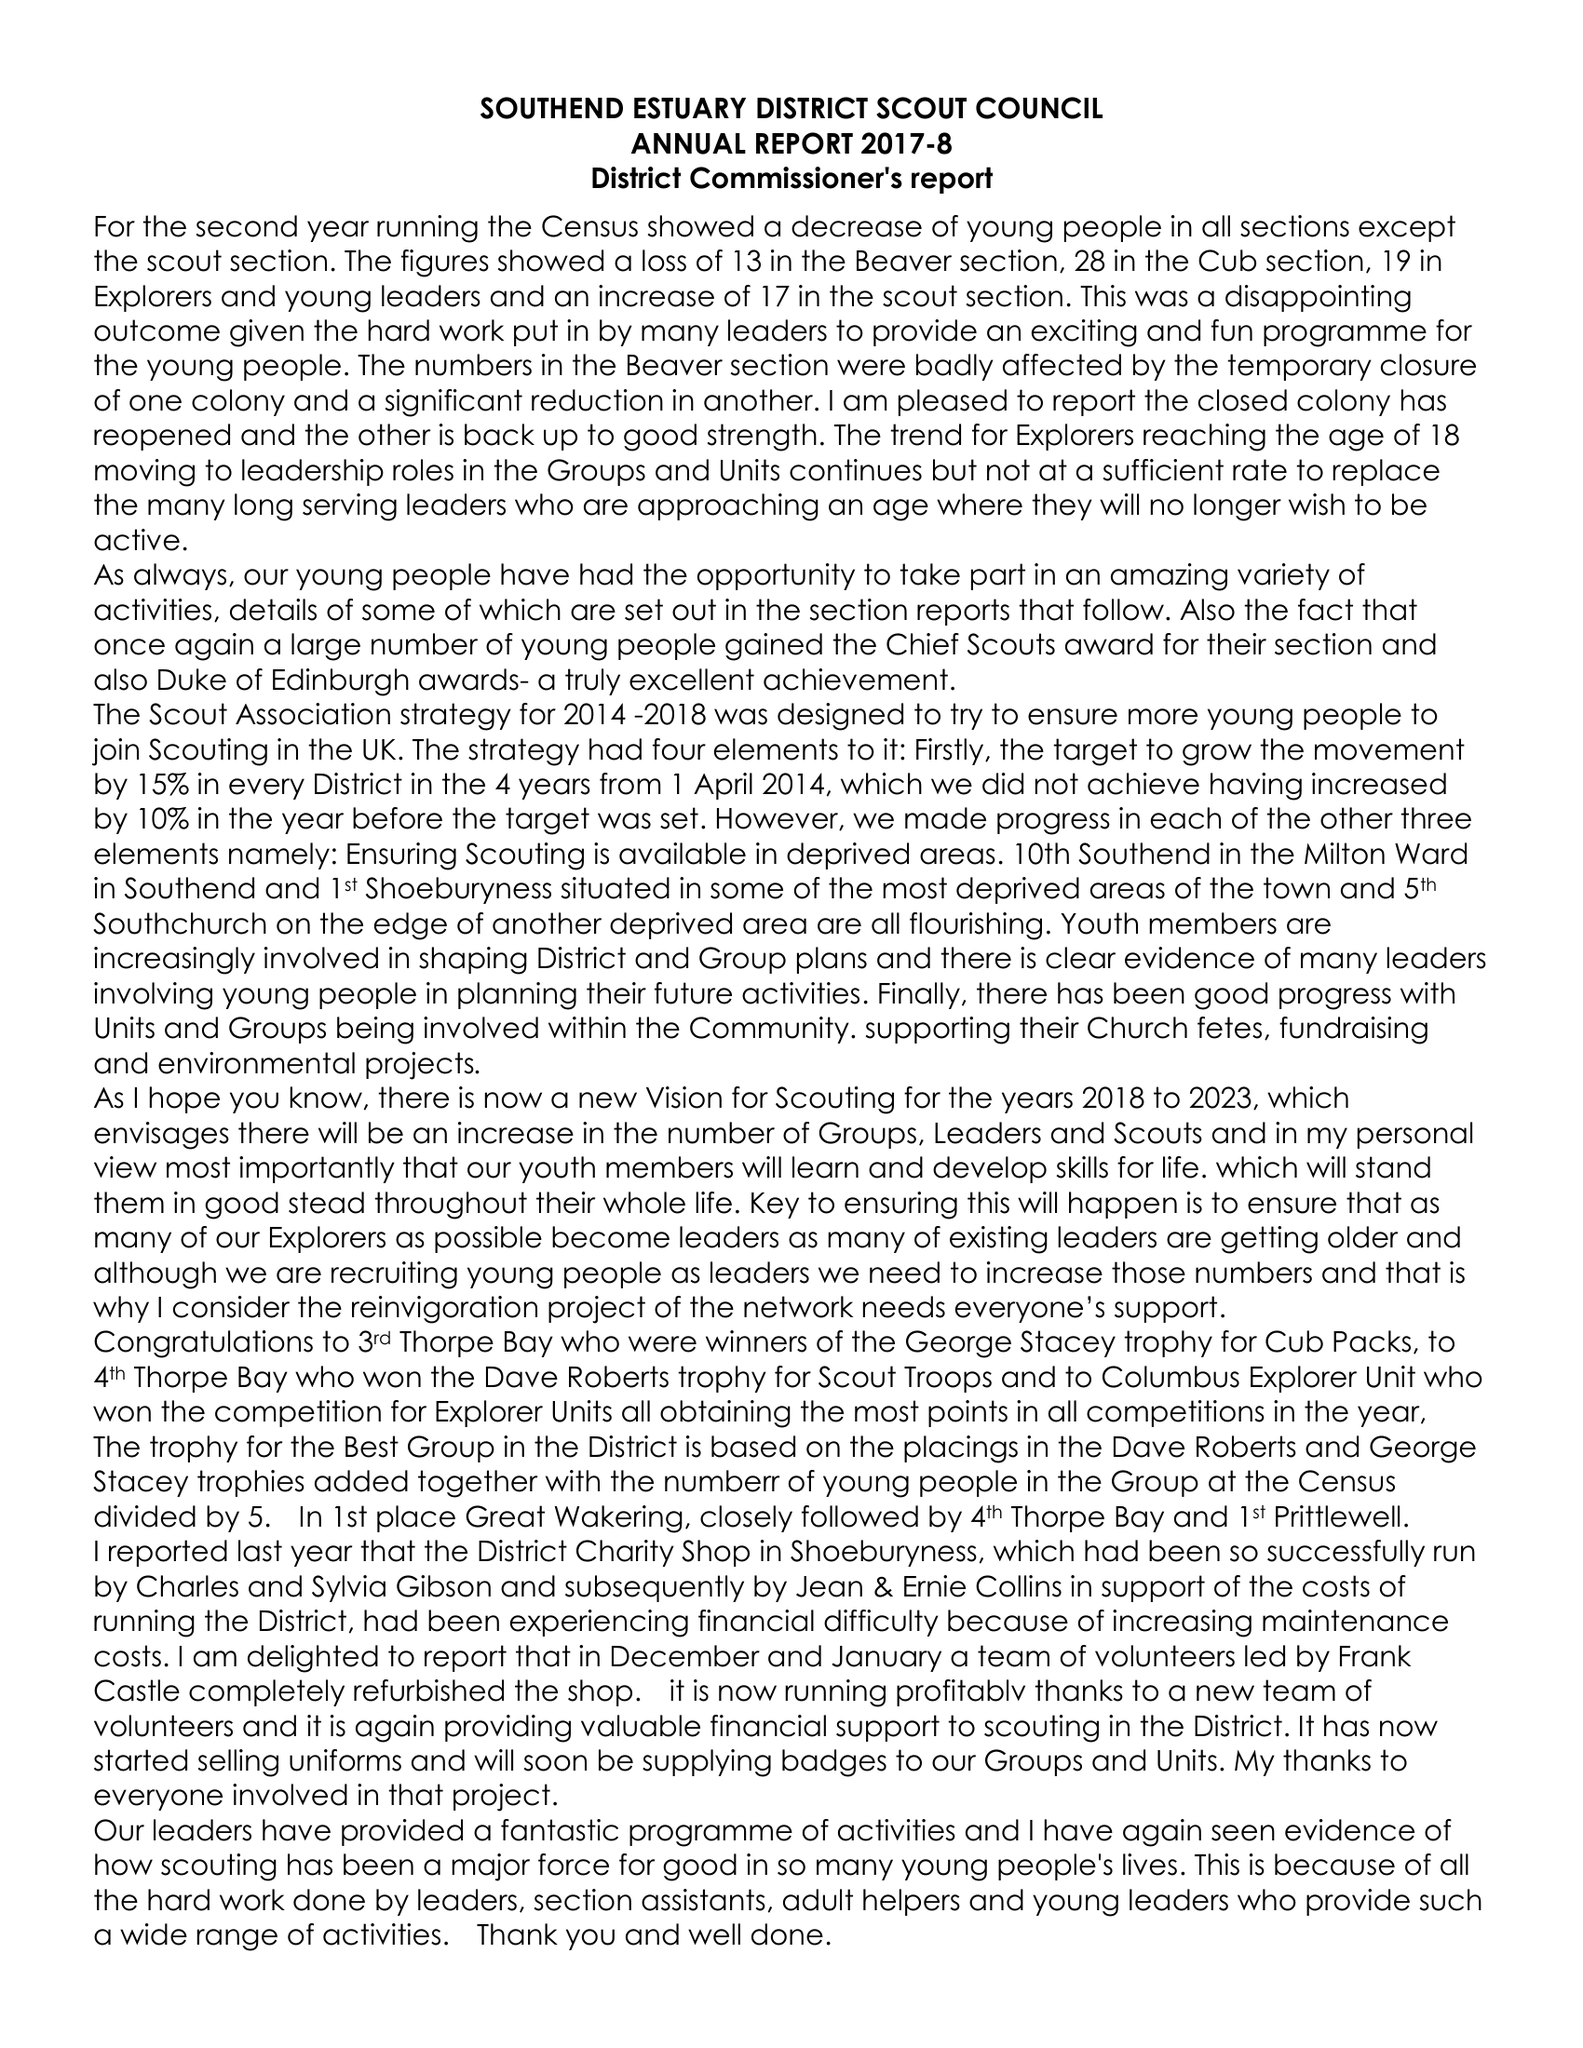What is the value for the spending_annually_in_british_pounds?
Answer the question using a single word or phrase. 94372.00 